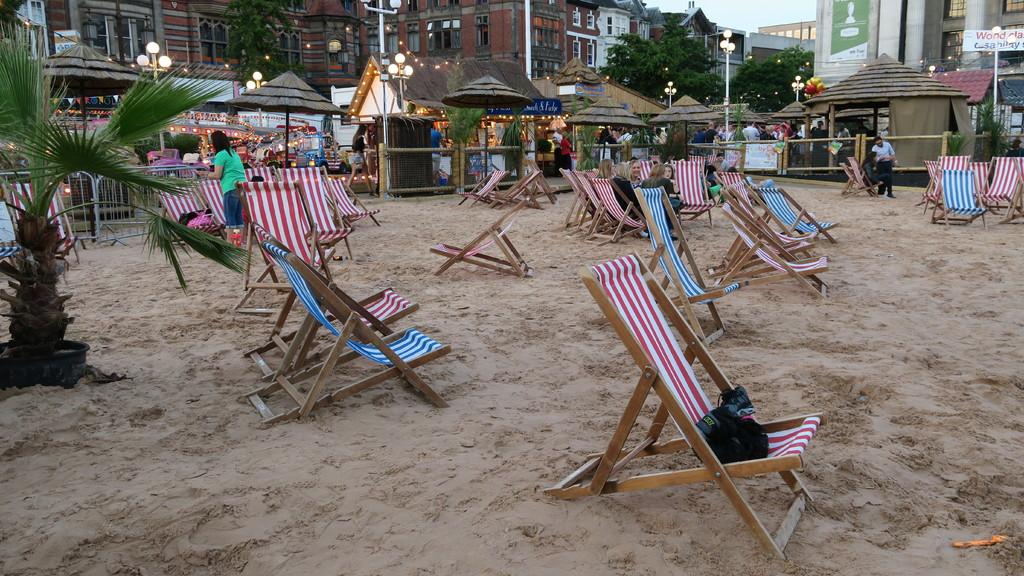What is the main subject of the image? The main subject of the image is a group of chairs in the sand. Are all the chairs in the image occupied? No, some chairs are left empty. Can you describe the surroundings of the chairs? There are buildings in the background. What type of pie is being served on the empty chairs? There is no pie present in the image, and the chairs are not serving any food. Can you tell me how many aunts are sitting on the occupied chairs? There is no mention of aunts in the image, and we cannot determine the number of people sitting on the chairs. 